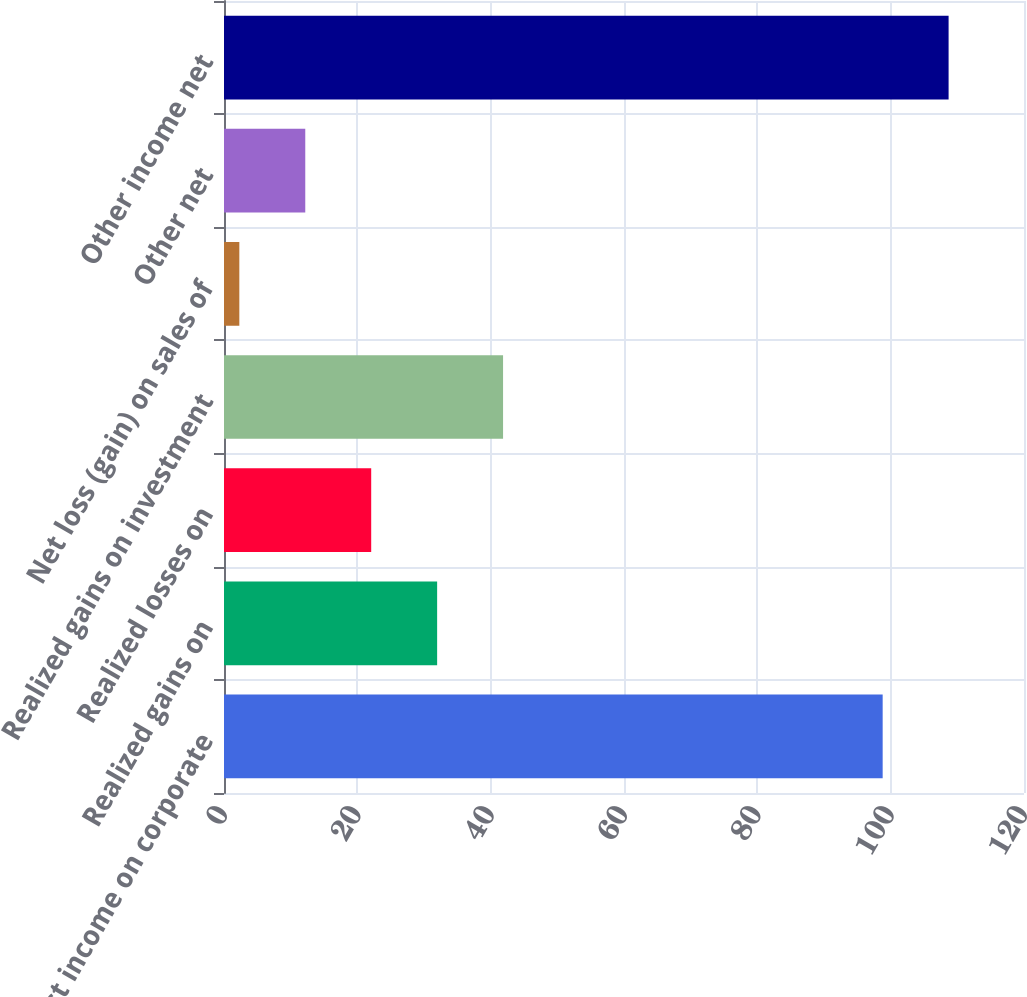Convert chart. <chart><loc_0><loc_0><loc_500><loc_500><bar_chart><fcel>Interest income on corporate<fcel>Realized gains on<fcel>Realized losses on<fcel>Realized gains on investment<fcel>Net loss (gain) on sales of<fcel>Other net<fcel>Other income net<nl><fcel>98.8<fcel>31.97<fcel>22.08<fcel>41.86<fcel>2.3<fcel>12.19<fcel>108.69<nl></chart> 